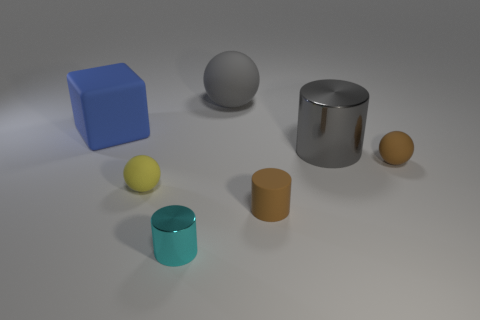The brown object that is the same shape as the gray rubber object is what size?
Ensure brevity in your answer.  Small. Is the color of the small matte cylinder the same as the large shiny thing?
Offer a very short reply. No. What number of other objects are the same material as the yellow thing?
Your answer should be very brief. 4. Are there an equal number of small brown balls on the left side of the small brown rubber ball and matte balls?
Provide a short and direct response. No. There is a matte ball to the left of the cyan cylinder; is it the same size as the small rubber cylinder?
Offer a terse response. Yes. There is a cyan cylinder; how many small objects are behind it?
Make the answer very short. 3. There is a cylinder that is in front of the yellow rubber object and behind the tiny cyan metal thing; what material is it made of?
Provide a succinct answer. Rubber. How many large things are either brown things or yellow rubber things?
Provide a short and direct response. 0. What is the size of the brown rubber ball?
Your answer should be compact. Small. The small shiny object is what shape?
Provide a short and direct response. Cylinder. 